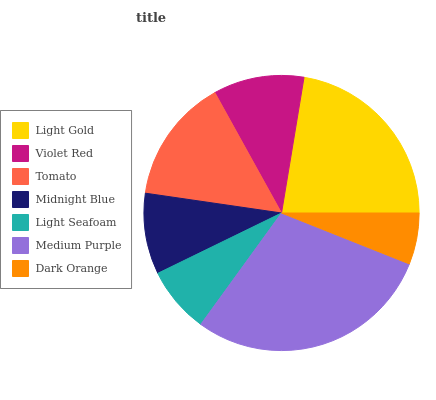Is Dark Orange the minimum?
Answer yes or no. Yes. Is Medium Purple the maximum?
Answer yes or no. Yes. Is Violet Red the minimum?
Answer yes or no. No. Is Violet Red the maximum?
Answer yes or no. No. Is Light Gold greater than Violet Red?
Answer yes or no. Yes. Is Violet Red less than Light Gold?
Answer yes or no. Yes. Is Violet Red greater than Light Gold?
Answer yes or no. No. Is Light Gold less than Violet Red?
Answer yes or no. No. Is Violet Red the high median?
Answer yes or no. Yes. Is Violet Red the low median?
Answer yes or no. Yes. Is Tomato the high median?
Answer yes or no. No. Is Dark Orange the low median?
Answer yes or no. No. 